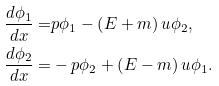Convert formula to latex. <formula><loc_0><loc_0><loc_500><loc_500>\frac { d \phi _ { 1 } } { d x } = & p \phi _ { 1 } - \left ( E + m \right ) u \phi _ { 2 } , \\ \frac { d \phi _ { 2 } } { d x } = & - p \phi _ { 2 } + \left ( E - m \right ) u \phi _ { 1 } .</formula> 